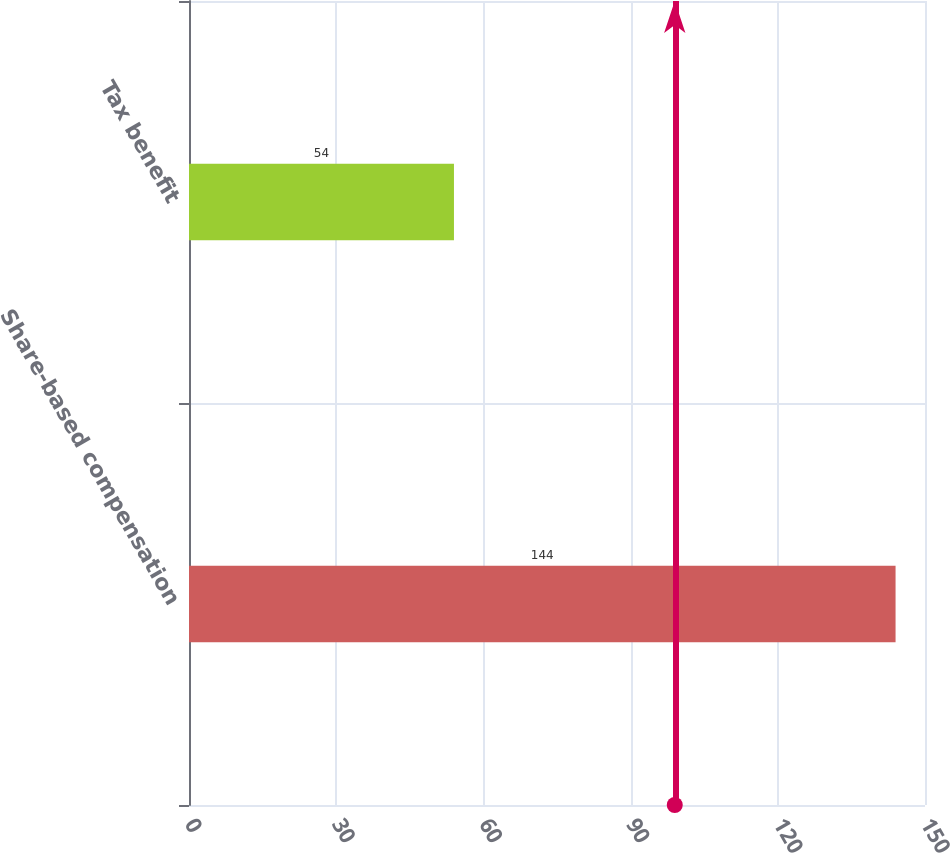<chart> <loc_0><loc_0><loc_500><loc_500><bar_chart><fcel>Share-based compensation<fcel>Tax benefit<nl><fcel>144<fcel>54<nl></chart> 